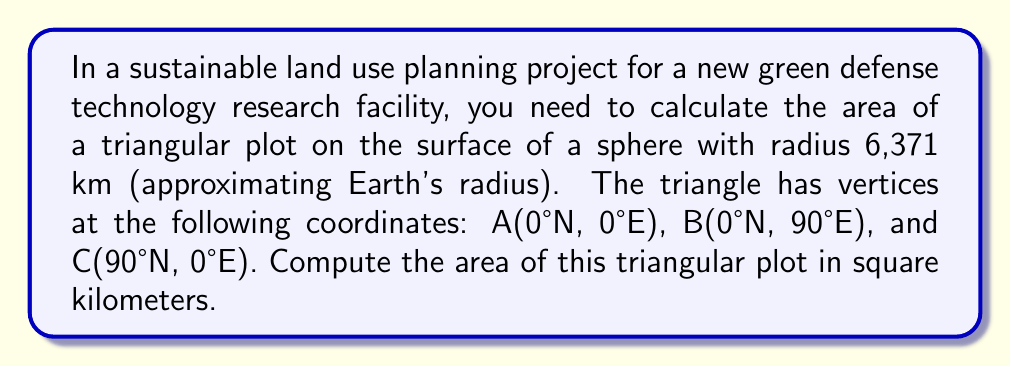Could you help me with this problem? To solve this problem, we'll use the formula for the area of a spherical triangle:

$$A = R^2 \cdot E$$

Where:
$A$ is the area of the spherical triangle
$R$ is the radius of the sphere
$E$ is the spherical excess in radians

Steps:

1) First, we need to calculate the angles of the spherical triangle:
   - Angle at A: 90°
   - Angle at B: 90°
   - Angle at C: 90°

2) The spherical excess $E$ is given by:
   $$E = (\alpha + \beta + \gamma) - \pi$$
   Where $\alpha$, $\beta$, and $\gamma$ are the angles of the spherical triangle in radians.

3) Convert the angles to radians:
   $$90° \cdot \frac{\pi}{180°} = \frac{\pi}{2}$$

4) Calculate the spherical excess:
   $$E = (\frac{\pi}{2} + \frac{\pi}{2} + \frac{\pi}{2}) - \pi = \frac{\pi}{2}$$

5) Now we can apply the formula:
   $$A = R^2 \cdot E$$
   $$A = (6371)^2 \cdot \frac{\pi}{2}$$
   $$A \approx 63,765,161.31 \text{ km}^2$$

This area represents one-eighth of the Earth's surface, which is expected for a triangle covering one-eighth of a sphere.
Answer: $63,765,161.31 \text{ km}^2$ 